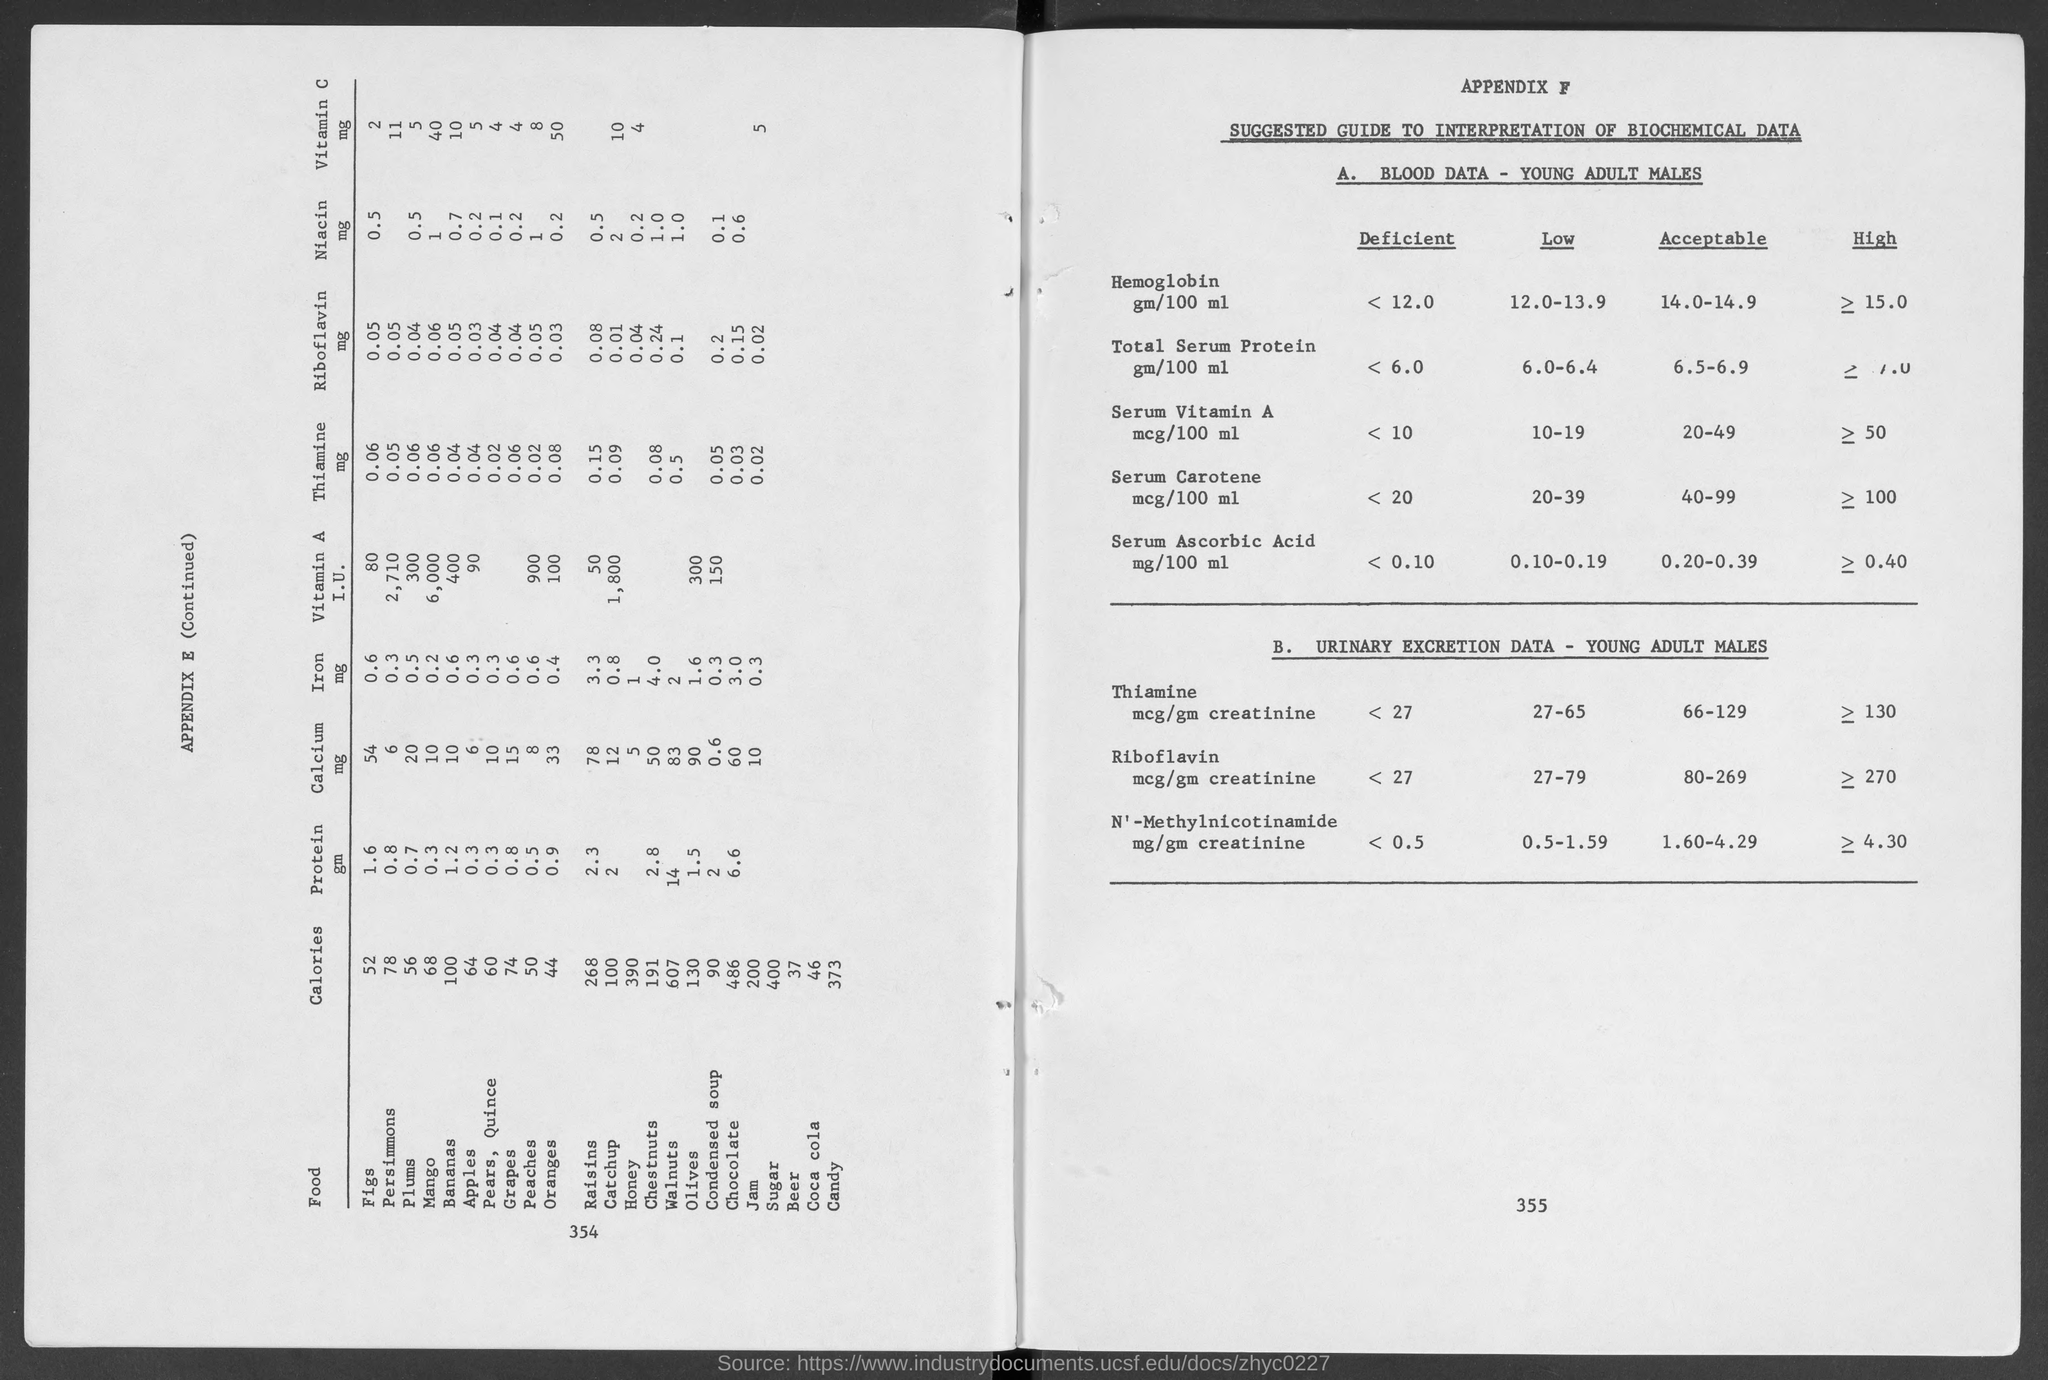What is APPENDIX F about?
Ensure brevity in your answer.  SUGGESTED GUIDE TO INTERPRETATION OF BIOCHEMICAL DATA. What is the acceptable level of Serum Carotene in mcg/100 ml in young adult males?
Give a very brief answer. 40-99. Which blood component has an acceptable range of 0.20-0.39 mg/100 ml?
Give a very brief answer. SERUM ASCORBIC ACID. Which food listed in APPENDIX E has lowest calories?
Offer a very short reply. Beer. What is the amount of Niacin in mg in Plums?
Offer a terse response. 0.5. 